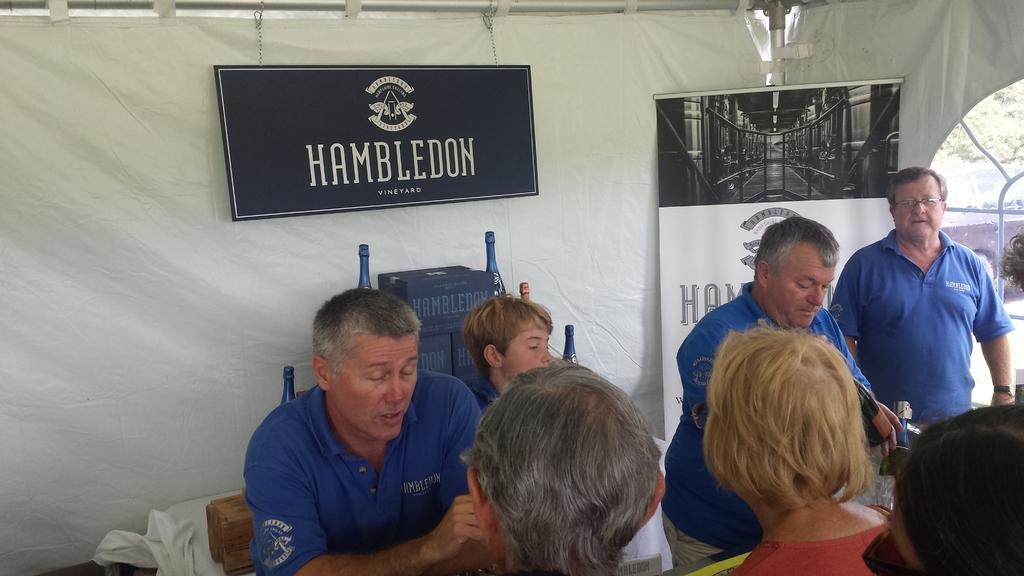What are the people in the image doing? The people in the image are standing under a tent. What can be seen in the background of the image? There are boards in the background of the image. What is written or depicted on the boards? There is text on the boards. What type of oatmeal is being served under the tent in the image? There is no oatmeal present in the image; it features people standing under a tent with boards in the background. What kind of hat is the representative wearing in the image? There is no representative or hat present in the image. 